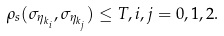<formula> <loc_0><loc_0><loc_500><loc_500>\rho _ { s } ( \sigma _ { \eta _ { k _ { i } } } , \sigma _ { \eta _ { k _ { j } } } ) \leq T , i , j = 0 , 1 , 2 .</formula> 